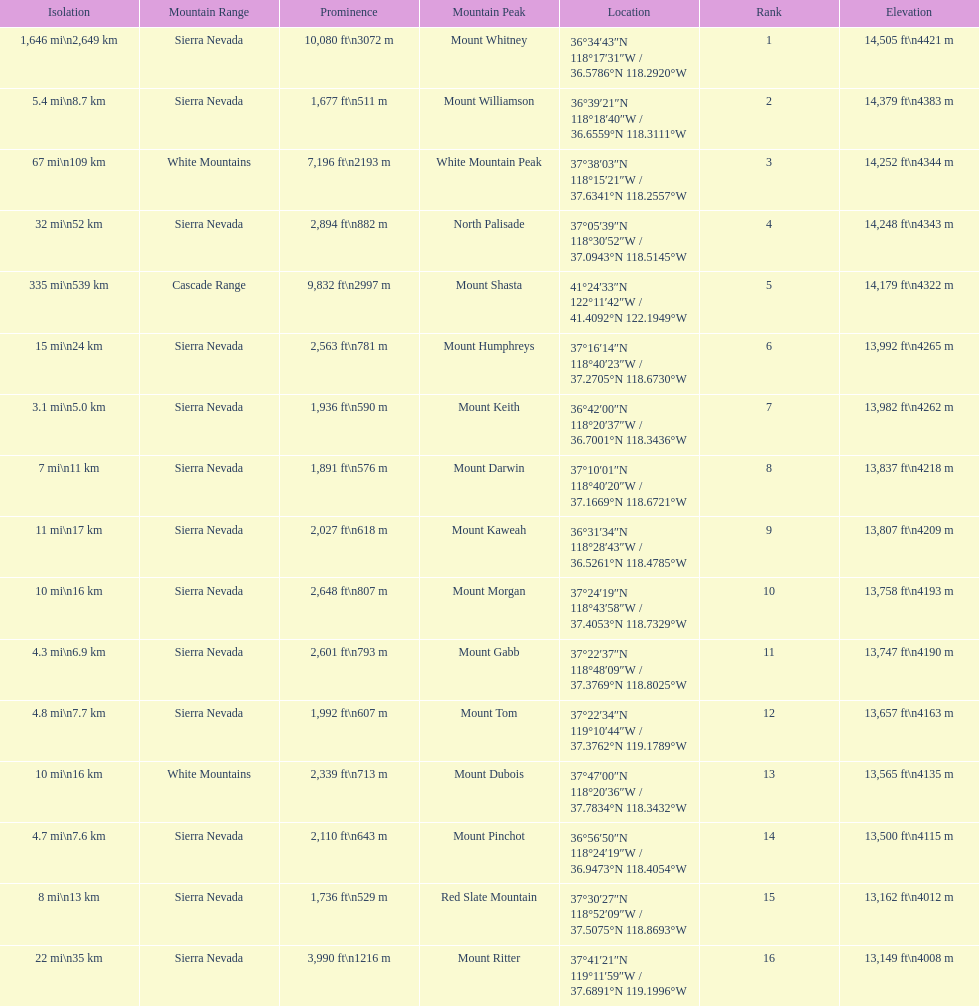What is the only mountain peak listed for the cascade range? Mount Shasta. 